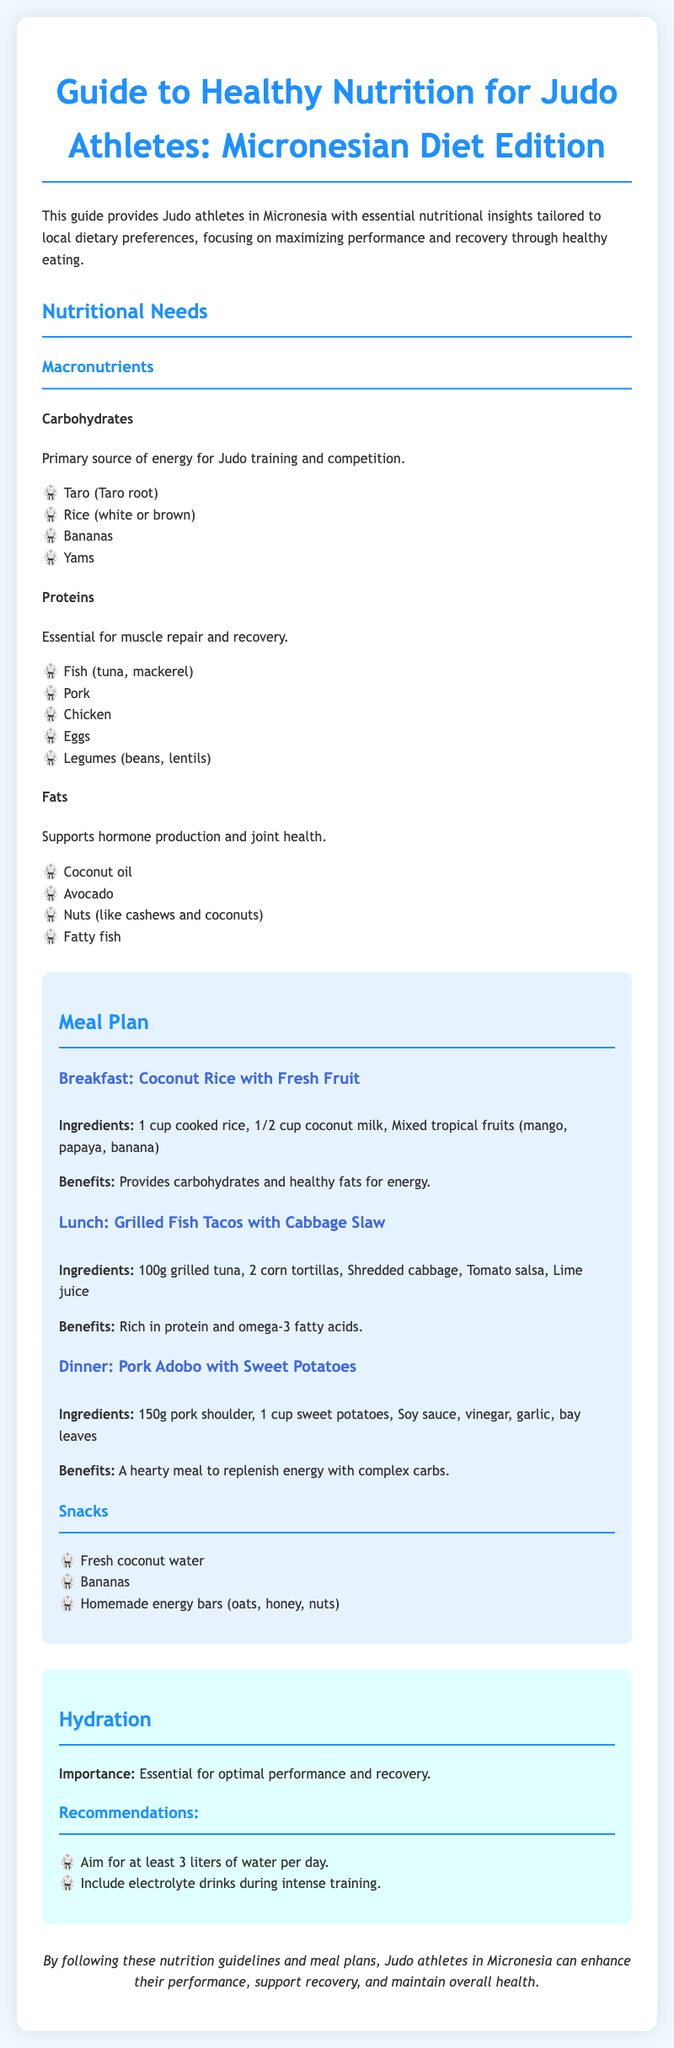What are the primary sources of carbohydrates? The document lists specific examples of carbohydrates essential for energy for Judo training, which are Taro, Rice, Bananas, and Yams.
Answer: Taro, Rice, Bananas, Yams What is recommended for hydration? The document outlines hydration recommendations for Judo athletes, which include drinking at least 3 liters of water daily and including electrolyte drinks during training.
Answer: 3 liters of water What type of meal is suggested for breakfast? The document provides a specific meal suggestion for breakfast, which includes certain ingredients and benefits.
Answer: Coconut Rice with Fresh Fruit What are the essential macronutrients for Judo athletes? The document mentions three main macronutrients that Judo athletes need, which are carbohydrates, proteins, and fats.
Answer: Carbohydrates, proteins, fats How many snacks are listed in the meal plan? The document contains a list of snack options available to Judo athletes and quantifies them.
Answer: Three snacks What benefits does pork adobo provide? The document explains the nutritional benefits of a specific meal, which includes replenishing energy with complex carbohydrates.
Answer: Replenish energy with complex carbs Which fish is included in the list of protein sources? The protein sources specified in the document include several types of fish, specifically tuna and mackerel.
Answer: Tuna, mackerel What is the significance of hydration according to the document? The guide emphasizes the role of hydration in the performance and recovery of Judo athletes.
Answer: Optimal performance and recovery 